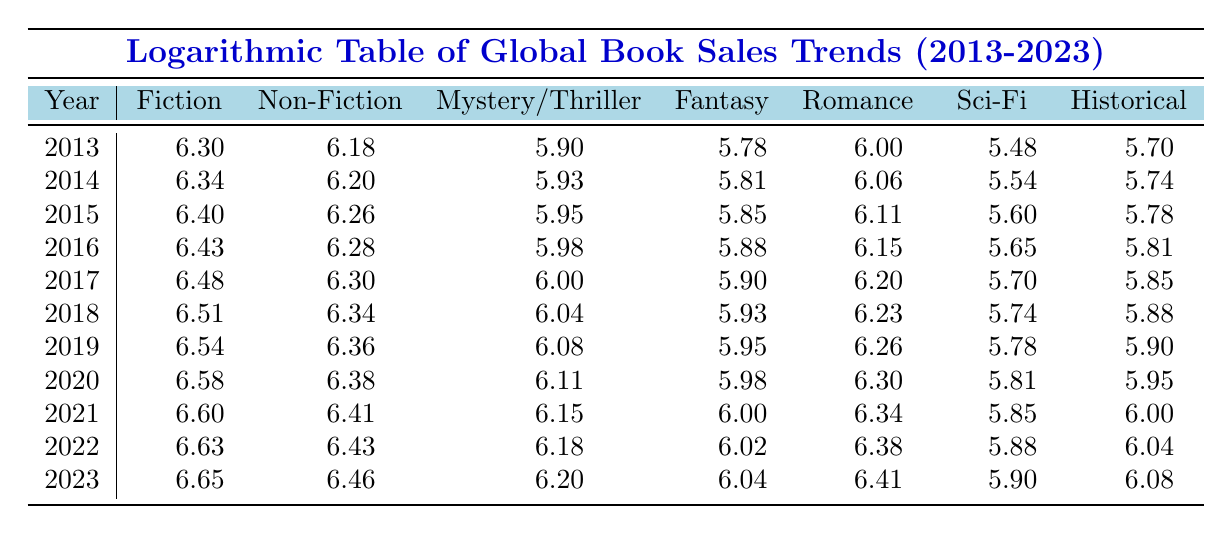What were the total book sales for Fiction in 2020? In 2020, the table shows that the Fiction sales amount to 3,800,000.
Answer: 3,800,000 Which genre had the highest sales in 2023? In 2023, the genre with the highest sales is Fiction at 4,500,000.
Answer: Fiction What is the difference in sales between Non-Fiction and Romance in 2019? In 2019, Non-Fiction sales were 2,300,000 and Romance sales were 1,800,000. The difference is 2,300,000 - 1,800,000 = 500,000.
Answer: 500,000 Has the sales for Science Fiction increased every year from 2013 to 2023? Observing the data, Science Fiction sales have increased from 300,000 in 2013 to 800,000 in 2023, indicating a consistent increase over the years.
Answer: Yes What was the average annual sales for Mystery/Thriller over the decade? The sales for Mystery/Thriller over the ten years are: 800,000, 850,000, 900,000, 950,000, 1,000,000, 1,100,000, 1,200,000, 1,300,000, 1,400,000, 1,500,000, 1,600,000. The sum of these sales is 11,950,000. Dividing this by 10 gives an average of 1,195,000.
Answer: 1,195,000 In which year did the sales for Historical books reach their peak? The peak sales for Historical books occurred in 2023 with a total of 1,200,000.
Answer: 2023 What were the total sales for Fantasy and Science Fiction combined in 2021? In 2021, Fantasy sales were 1,000,000 and Science Fiction sales were 700,000. The combined total is 1,000,000 + 700,000 = 1,700,000.
Answer: 1,700,000 Was the increase in Fiction sales from 2018 to 2019 greater than the increase from 2022 to 2023? The increase in Fiction sales from 2018 (3,200,000) to 2019 (3,500,000) is 300,000, while the increase from 2022 (4,300,000) to 2023 (4,500,000) is 200,000, which shows the increase from 2018 to 2019 was greater.
Answer: Yes 